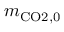<formula> <loc_0><loc_0><loc_500><loc_500>m _ { C O 2 , 0 }</formula> 